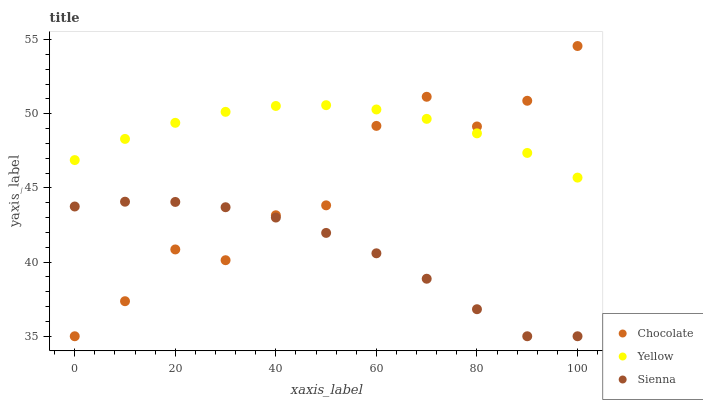Does Sienna have the minimum area under the curve?
Answer yes or no. Yes. Does Yellow have the maximum area under the curve?
Answer yes or no. Yes. Does Chocolate have the minimum area under the curve?
Answer yes or no. No. Does Chocolate have the maximum area under the curve?
Answer yes or no. No. Is Yellow the smoothest?
Answer yes or no. Yes. Is Chocolate the roughest?
Answer yes or no. Yes. Is Chocolate the smoothest?
Answer yes or no. No. Is Yellow the roughest?
Answer yes or no. No. Does Sienna have the lowest value?
Answer yes or no. Yes. Does Yellow have the lowest value?
Answer yes or no. No. Does Chocolate have the highest value?
Answer yes or no. Yes. Does Yellow have the highest value?
Answer yes or no. No. Is Sienna less than Yellow?
Answer yes or no. Yes. Is Yellow greater than Sienna?
Answer yes or no. Yes. Does Chocolate intersect Yellow?
Answer yes or no. Yes. Is Chocolate less than Yellow?
Answer yes or no. No. Is Chocolate greater than Yellow?
Answer yes or no. No. Does Sienna intersect Yellow?
Answer yes or no. No. 